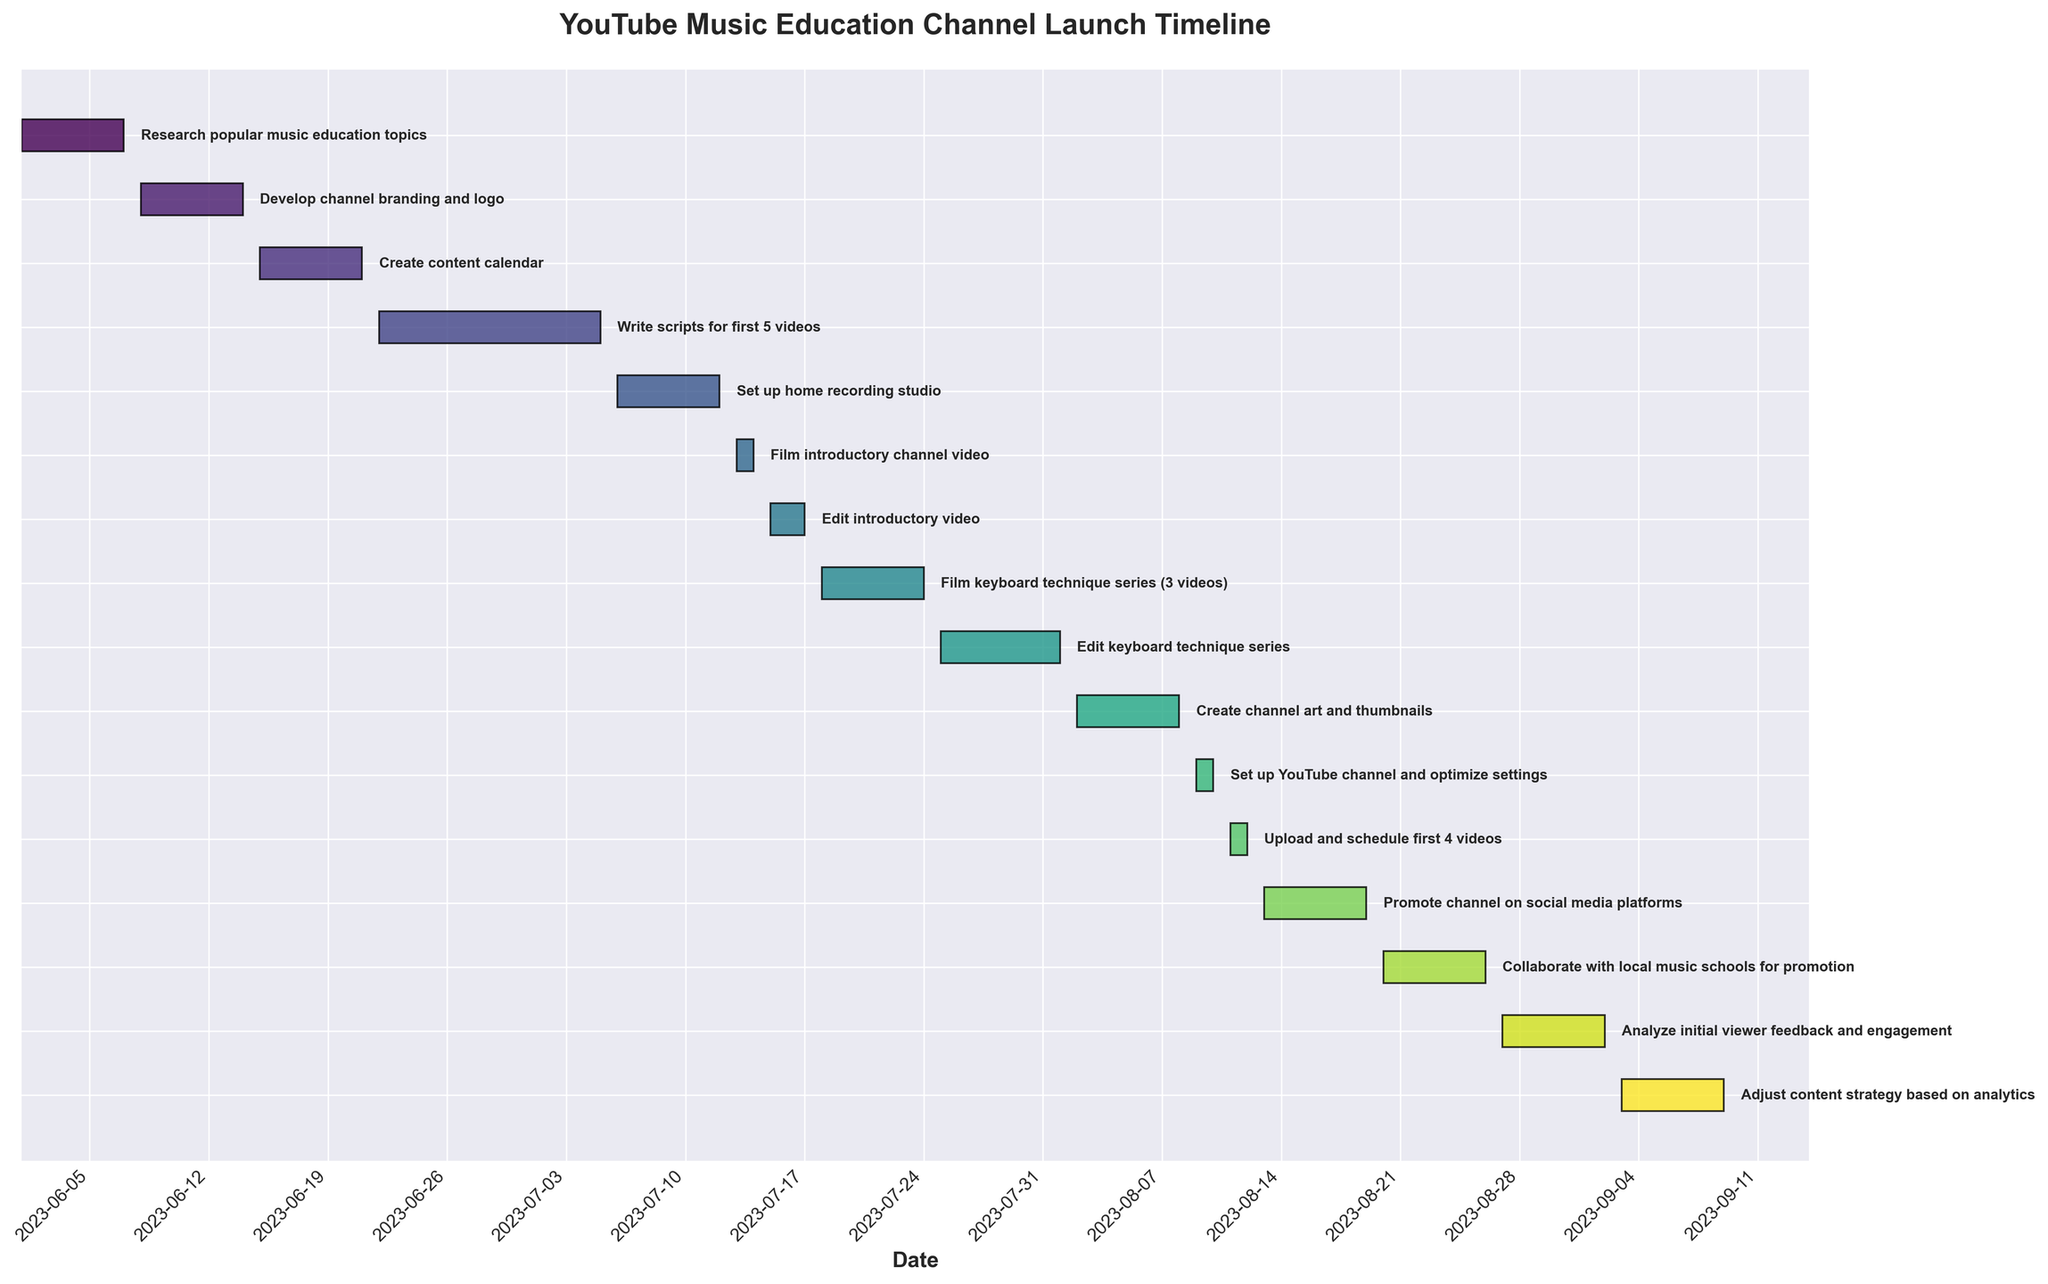What is the title of this Gantt Chart? The chart title is usually located at the top of the figure. In this case, it reads "YouTube Music Education Channel Launch Timeline".
Answer: YouTube Music Education Channel Launch Timeline How long is the task to "Edit introductory video"? The duration of the "Edit introductory video" task is shown as the length of the bar corresponding to this task. It spans 3 days.
Answer: 3 days Which task starts immediately after "Film introductory channel video"? By looking at the sequence of tasks, the task that follows "Film introductory channel video" on the timeline is "Edit introductory video".
Answer: Edit introductory video How many tasks are scheduled for August 2023? The tasks that occur in August based on the timeline are: "Edit keyboard technique series", "Create channel art and thumbnails", "Set up YouTube channel and optimize settings", "Upload and schedule first 4 videos", "Promote channel on social media platforms", and "Collaborate with local music schools for promotion". Counting these gives 6 tasks.
Answer: 6 tasks On which date range do the "Film keyboard technique series (3 videos)" take place? One can locate the "Film keyboard technique series (3 videos)" task on the Y-axis and refer to the corresponding horizontal bar, which starts on 2023-07-18 and ends on 2023-07-24.
Answer: 2023-07-18 to 2023-07-24 What is the total duration of the "Write scripts for first 5 videos" task in days? The task "Write scripts for first 5 videos" spans from 2023-06-22 to 2023-07-05. The duration in days is given as 14 days.
Answer: 14 days How many tasks take exactly 7 days to complete? By counting the bars with a length of 7 days, the tasks are: "Research popular music education topics", "Develop channel branding and logo", "Create content calendar", "Set up home recording studio", "Create channel art and thumbnails", "Promote channel on social media platforms", "Collaborate with local music schools for promotion", "Analyze initial viewer feedback and engagement", "Adjust content strategy based on analytics". This totals 9 tasks.
Answer: 9 tasks Which tasks have a duration less than a week? By examining the lengths of tasks-duration less than 7 days, the tasks are: "Film introductory channel video" (2 days), "Edit introductory video" (3 days), "Set up YouTube channel and optimize settings" (2 days), "Upload and schedule first 4 videos" (2 days).
Answer: Film introductory channel video, Edit introductory video, Set up YouTube channel and optimize settings, Upload and schedule first 4 videos What is the average duration of all tasks? The task durations in days are: 7, 7, 7, 14, 7, 2, 3, 7, 8, 7, 2, 2, 7, 7, 7, 7.The sum of all durations is 106 days. There are 16 tasks, so the average duration is 106/16.
Answer: 6.625 days 